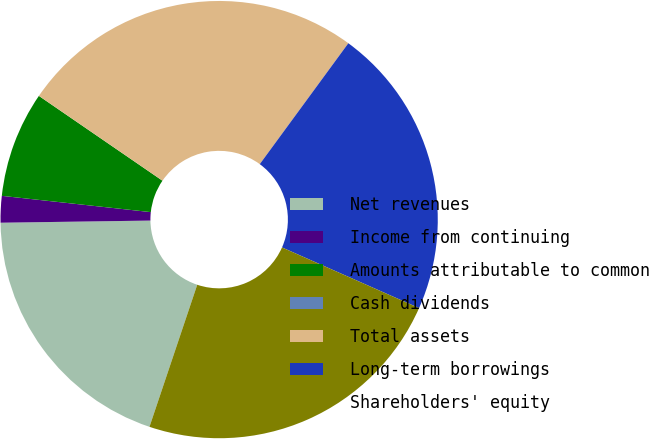<chart> <loc_0><loc_0><loc_500><loc_500><pie_chart><fcel>Net revenues<fcel>Income from continuing<fcel>Amounts attributable to common<fcel>Cash dividends<fcel>Total assets<fcel>Long-term borrowings<fcel>Shareholders' equity<nl><fcel>19.61%<fcel>1.96%<fcel>7.84%<fcel>0.0%<fcel>25.49%<fcel>21.57%<fcel>23.53%<nl></chart> 